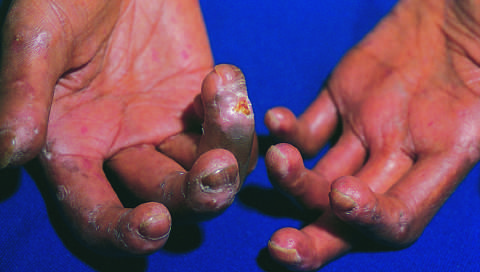does the immediate reaction have virtually immobilized the fingers, creating a clawlike flexion deformity?
Answer the question using a single word or phrase. No 